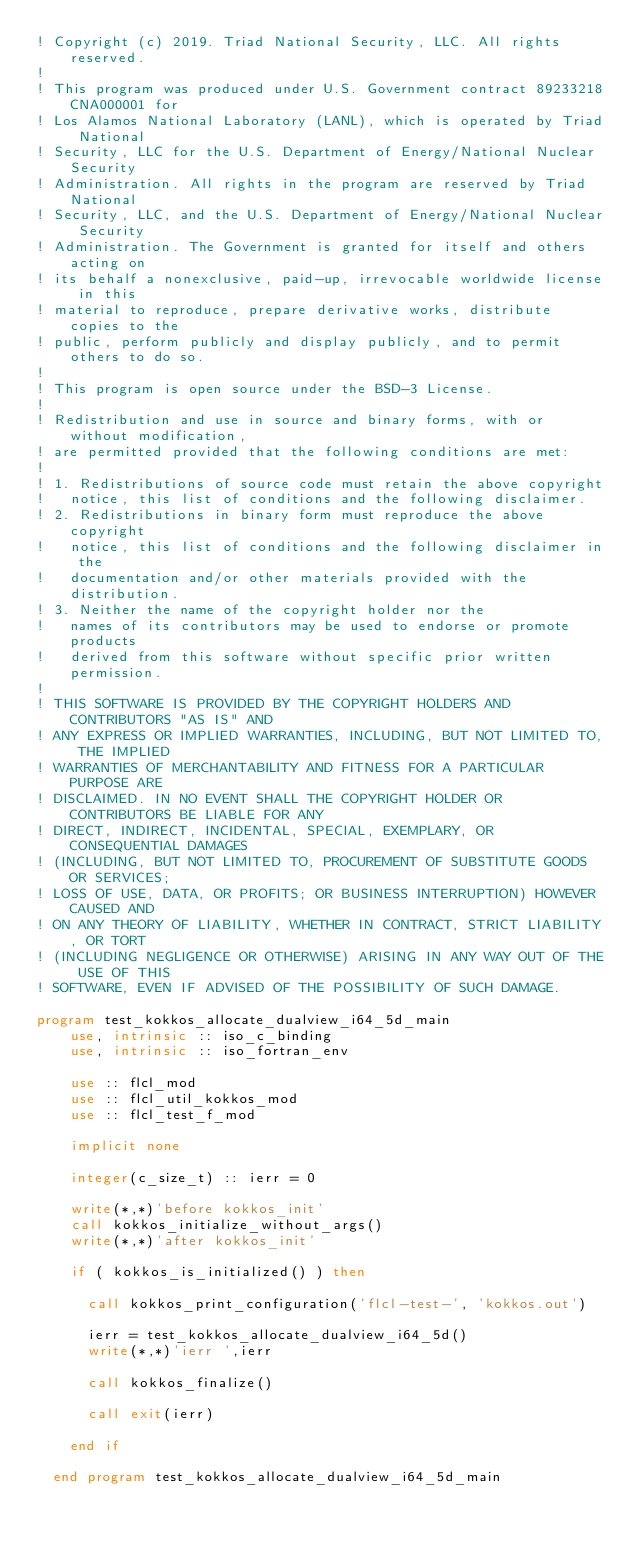Convert code to text. <code><loc_0><loc_0><loc_500><loc_500><_FORTRAN_>! Copyright (c) 2019. Triad National Security, LLC. All rights reserved.
!
! This program was produced under U.S. Government contract 89233218CNA000001 for
! Los Alamos National Laboratory (LANL), which is operated by Triad National
! Security, LLC for the U.S. Department of Energy/National Nuclear Security
! Administration. All rights in the program are reserved by Triad National
! Security, LLC, and the U.S. Department of Energy/National Nuclear Security
! Administration. The Government is granted for itself and others acting on
! its behalf a nonexclusive, paid-up, irrevocable worldwide license in this
! material to reproduce, prepare derivative works, distribute copies to the
! public, perform publicly and display publicly, and to permit others to do so.
!
! This program is open source under the BSD-3 License.
!
! Redistribution and use in source and binary forms, with or without modification,
! are permitted provided that the following conditions are met:
!
! 1. Redistributions of source code must retain the above copyright
!   notice, this list of conditions and the following disclaimer.
! 2. Redistributions in binary form must reproduce the above copyright
!   notice, this list of conditions and the following disclaimer in the
!   documentation and/or other materials provided with the distribution.
! 3. Neither the name of the copyright holder nor the
!   names of its contributors may be used to endorse or promote products
!   derived from this software without specific prior written permission.
!
! THIS SOFTWARE IS PROVIDED BY THE COPYRIGHT HOLDERS AND CONTRIBUTORS "AS IS" AND
! ANY EXPRESS OR IMPLIED WARRANTIES, INCLUDING, BUT NOT LIMITED TO, THE IMPLIED
! WARRANTIES OF MERCHANTABILITY AND FITNESS FOR A PARTICULAR PURPOSE ARE
! DISCLAIMED. IN NO EVENT SHALL THE COPYRIGHT HOLDER OR CONTRIBUTORS BE LIABLE FOR ANY
! DIRECT, INDIRECT, INCIDENTAL, SPECIAL, EXEMPLARY, OR CONSEQUENTIAL DAMAGES
! (INCLUDING, BUT NOT LIMITED TO, PROCUREMENT OF SUBSTITUTE GOODS OR SERVICES;
! LOSS OF USE, DATA, OR PROFITS; OR BUSINESS INTERRUPTION) HOWEVER CAUSED AND
! ON ANY THEORY OF LIABILITY, WHETHER IN CONTRACT, STRICT LIABILITY, OR TORT
! (INCLUDING NEGLIGENCE OR OTHERWISE) ARISING IN ANY WAY OUT OF THE USE OF THIS
! SOFTWARE, EVEN IF ADVISED OF THE POSSIBILITY OF SUCH DAMAGE.

program test_kokkos_allocate_dualview_i64_5d_main
    use, intrinsic :: iso_c_binding
    use, intrinsic :: iso_fortran_env
  
    use :: flcl_mod
    use :: flcl_util_kokkos_mod
    use :: flcl_test_f_mod
  
    implicit none
  
    integer(c_size_t) :: ierr = 0
  
    write(*,*)'before kokkos_init'
    call kokkos_initialize_without_args()
    write(*,*)'after kokkos_init'

    if ( kokkos_is_initialized() ) then
      
      call kokkos_print_configuration('flcl-test-', 'kokkos.out')
  
      ierr = test_kokkos_allocate_dualview_i64_5d()
      write(*,*)'ierr ',ierr
  
      call kokkos_finalize()
  
      call exit(ierr)

    end if
    
  end program test_kokkos_allocate_dualview_i64_5d_main
</code> 